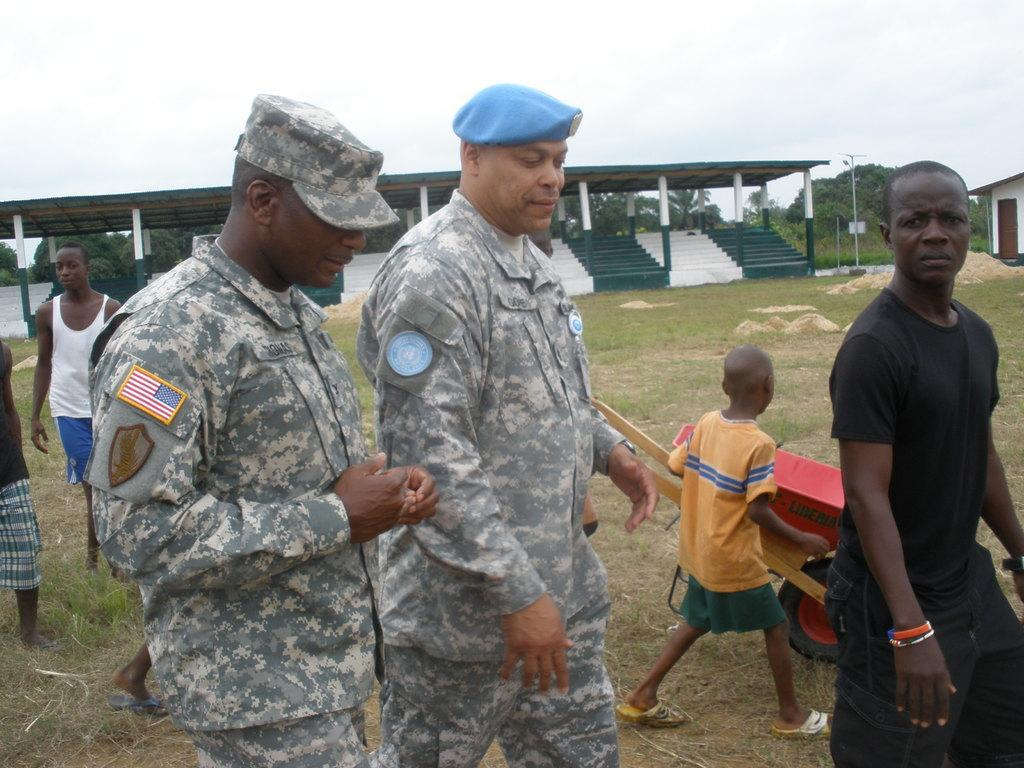Who or what can be seen in the image? There are people in the image. What object is on the grass in the image? There is a cart on the grass. What structures can be seen in the background of the image? There are sheds, poles, and trees in the background of the image. What architectural feature is present in the background of the image? There are steps in the background of the image. What part of the natural environment is visible in the background of the image? The sky is visible in the background of the image. What type of stomach ache is the person experiencing in the image? There is no indication of anyone experiencing a stomach ache in the image. What type of field is visible in the image? There is no field visible in the image; it features a cart on the grass and various structures in the background. 